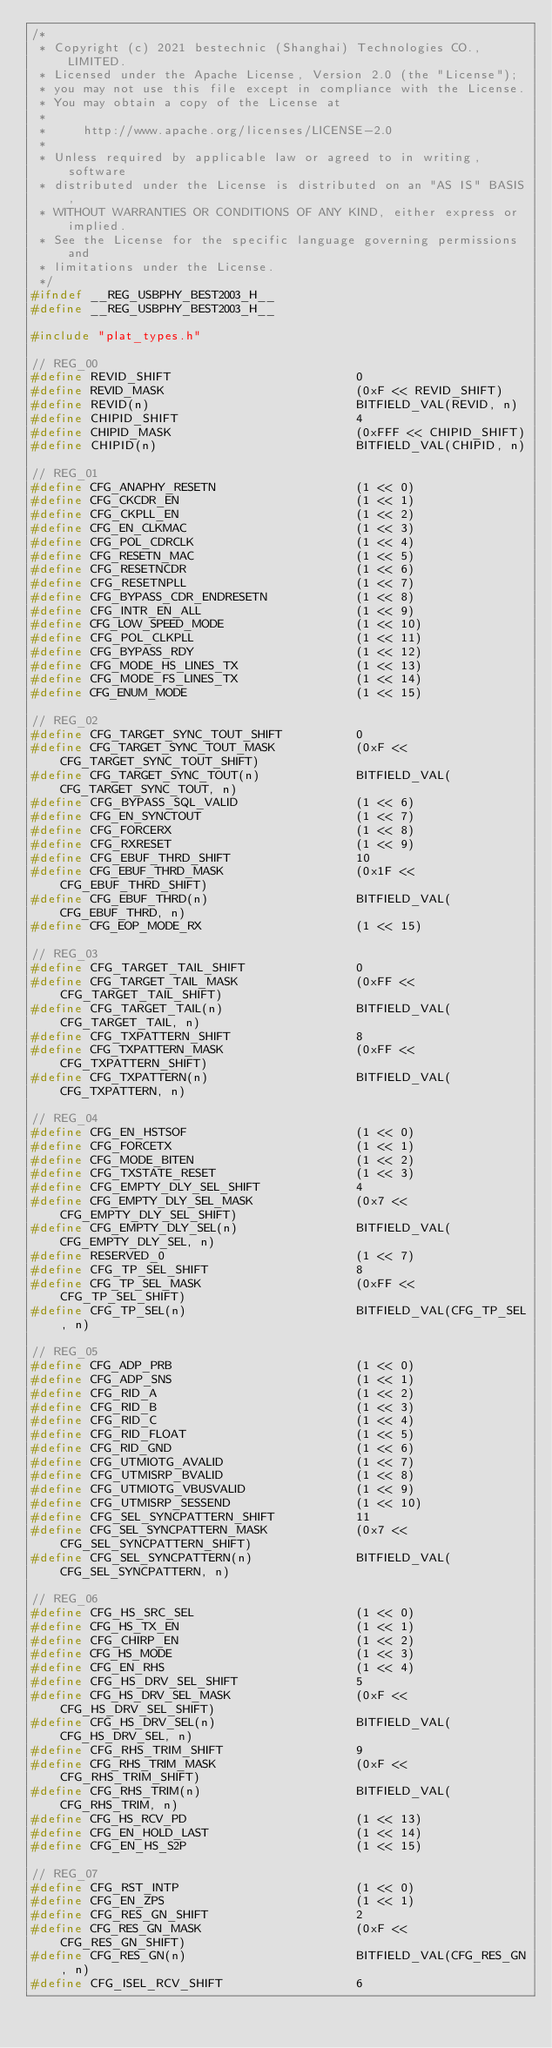<code> <loc_0><loc_0><loc_500><loc_500><_C_>/*
 * Copyright (c) 2021 bestechnic (Shanghai) Technologies CO., LIMITED.
 * Licensed under the Apache License, Version 2.0 (the "License");
 * you may not use this file except in compliance with the License.
 * You may obtain a copy of the License at
 *
 *     http://www.apache.org/licenses/LICENSE-2.0
 *
 * Unless required by applicable law or agreed to in writing, software
 * distributed under the License is distributed on an "AS IS" BASIS,
 * WITHOUT WARRANTIES OR CONDITIONS OF ANY KIND, either express or implied.
 * See the License for the specific language governing permissions and
 * limitations under the License.
 */
#ifndef __REG_USBPHY_BEST2003_H__
#define __REG_USBPHY_BEST2003_H__

#include "plat_types.h"

// REG_00
#define REVID_SHIFT                         0
#define REVID_MASK                          (0xF << REVID_SHIFT)
#define REVID(n)                            BITFIELD_VAL(REVID, n)
#define CHIPID_SHIFT                        4
#define CHIPID_MASK                         (0xFFF << CHIPID_SHIFT)
#define CHIPID(n)                           BITFIELD_VAL(CHIPID, n)

// REG_01
#define CFG_ANAPHY_RESETN                   (1 << 0)
#define CFG_CKCDR_EN                        (1 << 1)
#define CFG_CKPLL_EN                        (1 << 2)
#define CFG_EN_CLKMAC                       (1 << 3)
#define CFG_POL_CDRCLK                      (1 << 4)
#define CFG_RESETN_MAC                      (1 << 5)
#define CFG_RESETNCDR                       (1 << 6)
#define CFG_RESETNPLL                       (1 << 7)
#define CFG_BYPASS_CDR_ENDRESETN            (1 << 8)
#define CFG_INTR_EN_ALL                     (1 << 9)
#define CFG_LOW_SPEED_MODE                  (1 << 10)
#define CFG_POL_CLKPLL                      (1 << 11)
#define CFG_BYPASS_RDY                      (1 << 12)
#define CFG_MODE_HS_LINES_TX                (1 << 13)
#define CFG_MODE_FS_LINES_TX                (1 << 14)
#define CFG_ENUM_MODE                       (1 << 15)

// REG_02
#define CFG_TARGET_SYNC_TOUT_SHIFT          0
#define CFG_TARGET_SYNC_TOUT_MASK           (0xF << CFG_TARGET_SYNC_TOUT_SHIFT)
#define CFG_TARGET_SYNC_TOUT(n)             BITFIELD_VAL(CFG_TARGET_SYNC_TOUT, n)
#define CFG_BYPASS_SQL_VALID                (1 << 6)
#define CFG_EN_SYNCTOUT                     (1 << 7)
#define CFG_FORCERX                         (1 << 8)
#define CFG_RXRESET                         (1 << 9)
#define CFG_EBUF_THRD_SHIFT                 10
#define CFG_EBUF_THRD_MASK                  (0x1F << CFG_EBUF_THRD_SHIFT)
#define CFG_EBUF_THRD(n)                    BITFIELD_VAL(CFG_EBUF_THRD, n)
#define CFG_EOP_MODE_RX                     (1 << 15)

// REG_03
#define CFG_TARGET_TAIL_SHIFT               0
#define CFG_TARGET_TAIL_MASK                (0xFF << CFG_TARGET_TAIL_SHIFT)
#define CFG_TARGET_TAIL(n)                  BITFIELD_VAL(CFG_TARGET_TAIL, n)
#define CFG_TXPATTERN_SHIFT                 8
#define CFG_TXPATTERN_MASK                  (0xFF << CFG_TXPATTERN_SHIFT)
#define CFG_TXPATTERN(n)                    BITFIELD_VAL(CFG_TXPATTERN, n)

// REG_04
#define CFG_EN_HSTSOF                       (1 << 0)
#define CFG_FORCETX                         (1 << 1)
#define CFG_MODE_BITEN                      (1 << 2)
#define CFG_TXSTATE_RESET                   (1 << 3)
#define CFG_EMPTY_DLY_SEL_SHIFT             4
#define CFG_EMPTY_DLY_SEL_MASK              (0x7 << CFG_EMPTY_DLY_SEL_SHIFT)
#define CFG_EMPTY_DLY_SEL(n)                BITFIELD_VAL(CFG_EMPTY_DLY_SEL, n)
#define RESERVED_0                          (1 << 7)
#define CFG_TP_SEL_SHIFT                    8
#define CFG_TP_SEL_MASK                     (0xFF << CFG_TP_SEL_SHIFT)
#define CFG_TP_SEL(n)                       BITFIELD_VAL(CFG_TP_SEL, n)

// REG_05
#define CFG_ADP_PRB                         (1 << 0)
#define CFG_ADP_SNS                         (1 << 1)
#define CFG_RID_A                           (1 << 2)
#define CFG_RID_B                           (1 << 3)
#define CFG_RID_C                           (1 << 4)
#define CFG_RID_FLOAT                       (1 << 5)
#define CFG_RID_GND                         (1 << 6)
#define CFG_UTMIOTG_AVALID                  (1 << 7)
#define CFG_UTMISRP_BVALID                  (1 << 8)
#define CFG_UTMIOTG_VBUSVALID               (1 << 9)
#define CFG_UTMISRP_SESSEND                 (1 << 10)
#define CFG_SEL_SYNCPATTERN_SHIFT           11
#define CFG_SEL_SYNCPATTERN_MASK            (0x7 << CFG_SEL_SYNCPATTERN_SHIFT)
#define CFG_SEL_SYNCPATTERN(n)              BITFIELD_VAL(CFG_SEL_SYNCPATTERN, n)

// REG_06
#define CFG_HS_SRC_SEL                      (1 << 0)
#define CFG_HS_TX_EN                        (1 << 1)
#define CFG_CHIRP_EN                        (1 << 2)
#define CFG_HS_MODE                         (1 << 3)
#define CFG_EN_RHS                          (1 << 4)
#define CFG_HS_DRV_SEL_SHIFT                5
#define CFG_HS_DRV_SEL_MASK                 (0xF << CFG_HS_DRV_SEL_SHIFT)
#define CFG_HS_DRV_SEL(n)                   BITFIELD_VAL(CFG_HS_DRV_SEL, n)
#define CFG_RHS_TRIM_SHIFT                  9
#define CFG_RHS_TRIM_MASK                   (0xF << CFG_RHS_TRIM_SHIFT)
#define CFG_RHS_TRIM(n)                     BITFIELD_VAL(CFG_RHS_TRIM, n)
#define CFG_HS_RCV_PD                       (1 << 13)
#define CFG_EN_HOLD_LAST                    (1 << 14)
#define CFG_EN_HS_S2P                       (1 << 15)

// REG_07
#define CFG_RST_INTP                        (1 << 0)
#define CFG_EN_ZPS                          (1 << 1)
#define CFG_RES_GN_SHIFT                    2
#define CFG_RES_GN_MASK                     (0xF << CFG_RES_GN_SHIFT)
#define CFG_RES_GN(n)                       BITFIELD_VAL(CFG_RES_GN, n)
#define CFG_ISEL_RCV_SHIFT                  6</code> 